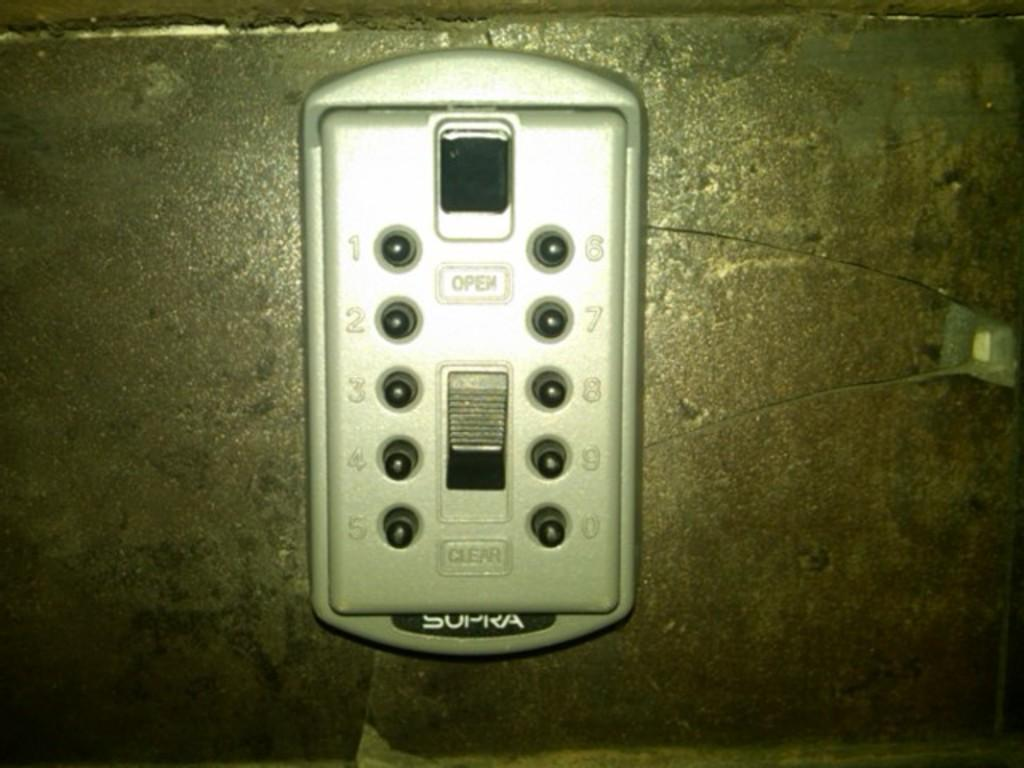<image>
Describe the image concisely. A device made from Sopra rests on a surface. 